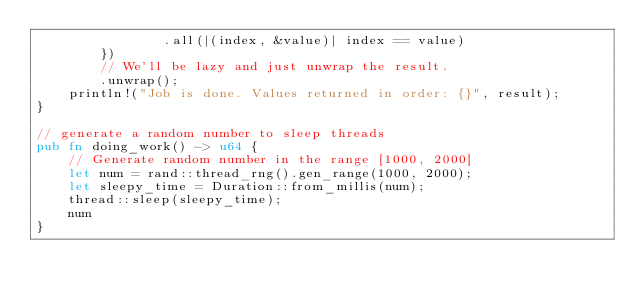Convert code to text. <code><loc_0><loc_0><loc_500><loc_500><_Rust_>                .all(|(index, &value)| index == value)
        })
        // We'll be lazy and just unwrap the result.
        .unwrap();
    println!("Job is done. Values returned in order: {}", result);
}

// generate a random number to sleep threads
pub fn doing_work() -> u64 {
    // Generate random number in the range [1000, 2000]
    let num = rand::thread_rng().gen_range(1000, 2000);
    let sleepy_time = Duration::from_millis(num);
    thread::sleep(sleepy_time);
    num
}
</code> 